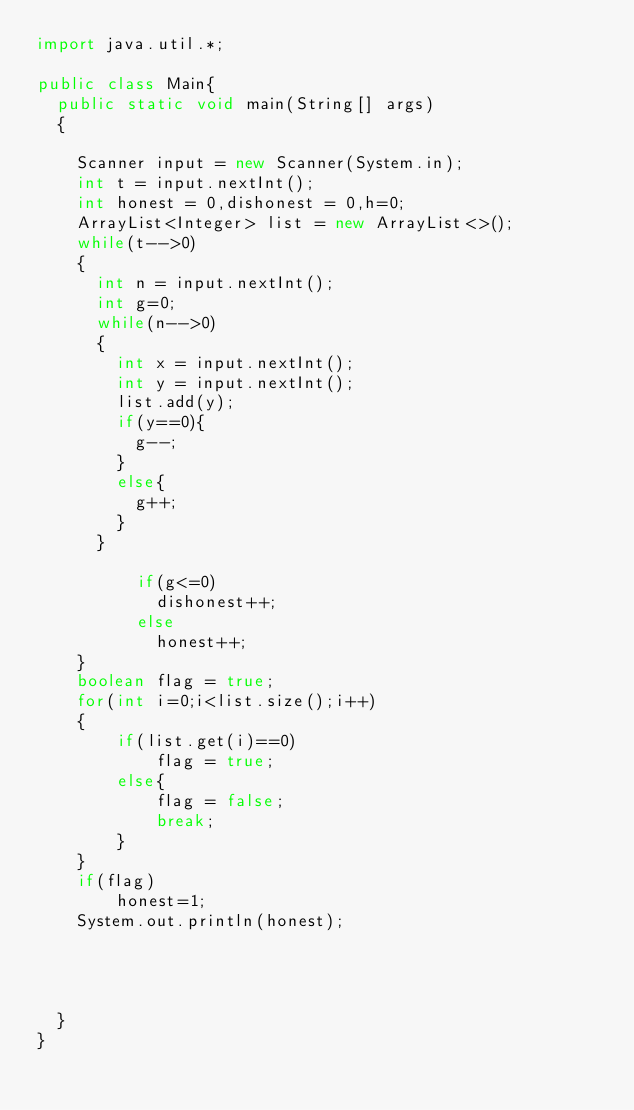<code> <loc_0><loc_0><loc_500><loc_500><_Java_>import java.util.*;

public class Main{
  public static void main(String[] args)
  {
    
    Scanner input = new Scanner(System.in);
    int t = input.nextInt();
    int honest = 0,dishonest = 0,h=0;
    ArrayList<Integer> list = new ArrayList<>();
    while(t-->0)
    {
      int n = input.nextInt();
      int g=0;
      while(n-->0)
      {
        int x = input.nextInt();
        int y = input.nextInt();
        list.add(y);
        if(y==0){
          g--;
        }
       	else{
          g++;
        }
      }
      
          if(g<=0)
            dishonest++;
          else
            honest++;
    }
    boolean flag = true;
    for(int i=0;i<list.size();i++)
    {
        if(list.get(i)==0)
            flag = true;
        else{
            flag = false;
            break;
        }
    }
    if(flag)
        honest=1;
    System.out.println(honest);
    
    
    
    
  }
}
</code> 